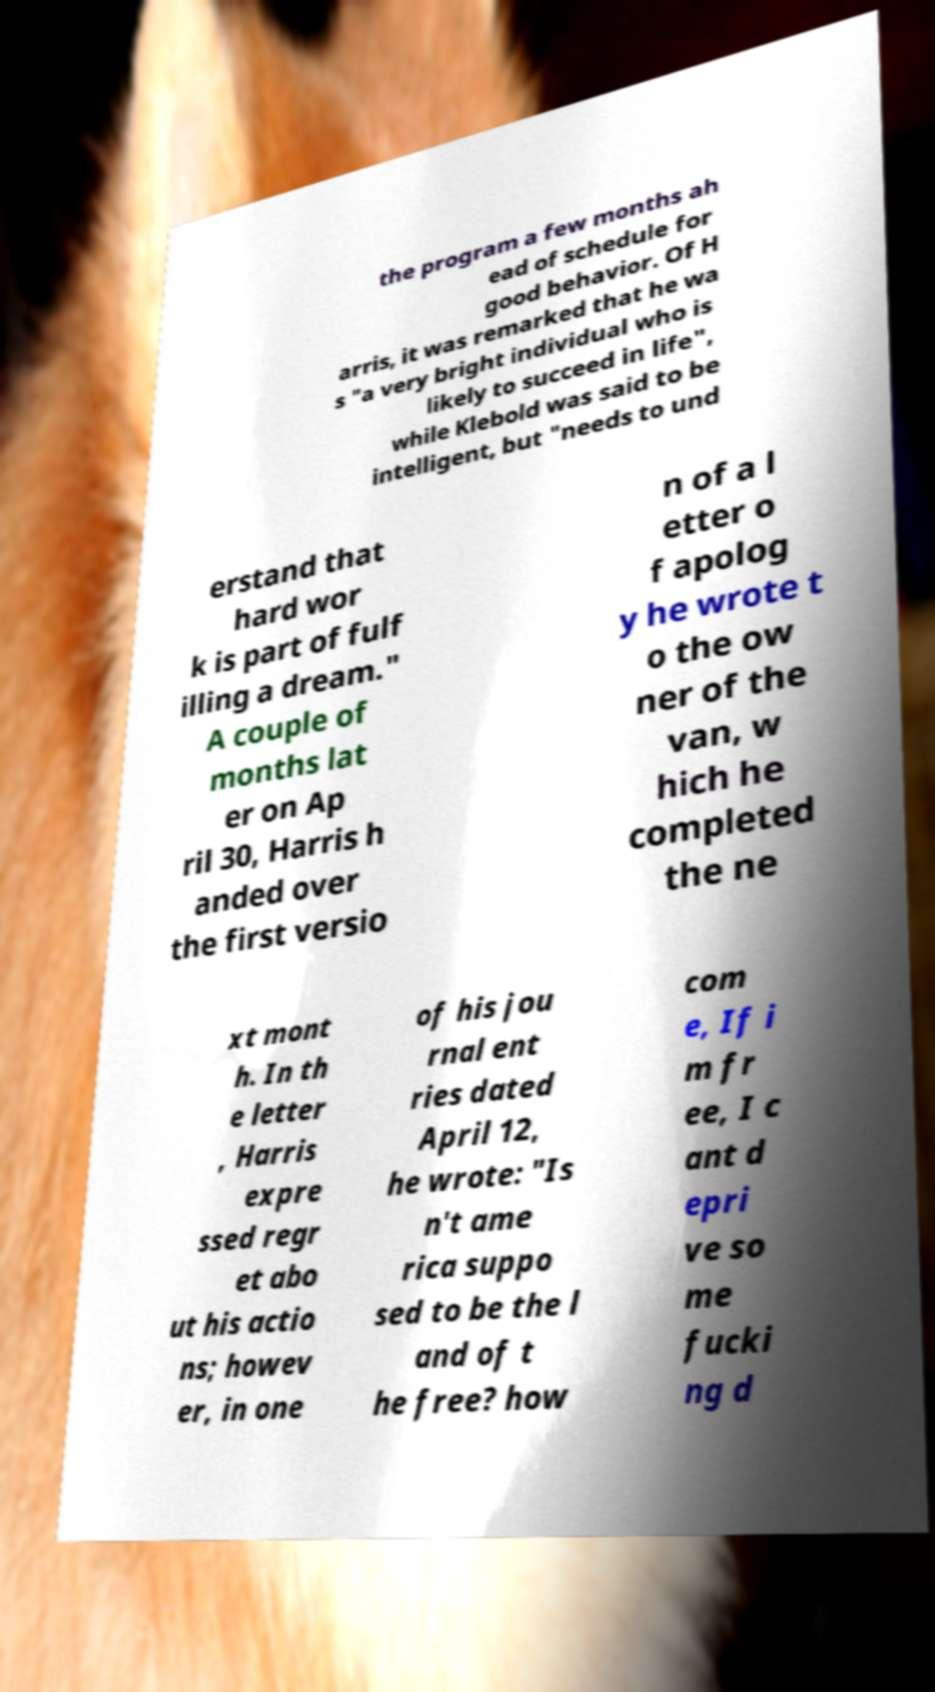Could you extract and type out the text from this image? the program a few months ah ead of schedule for good behavior. Of H arris, it was remarked that he wa s "a very bright individual who is likely to succeed in life", while Klebold was said to be intelligent, but "needs to und erstand that hard wor k is part of fulf illing a dream." A couple of months lat er on Ap ril 30, Harris h anded over the first versio n of a l etter o f apolog y he wrote t o the ow ner of the van, w hich he completed the ne xt mont h. In th e letter , Harris expre ssed regr et abo ut his actio ns; howev er, in one of his jou rnal ent ries dated April 12, he wrote: "Is n't ame rica suppo sed to be the l and of t he free? how com e, If i m fr ee, I c ant d epri ve so me fucki ng d 